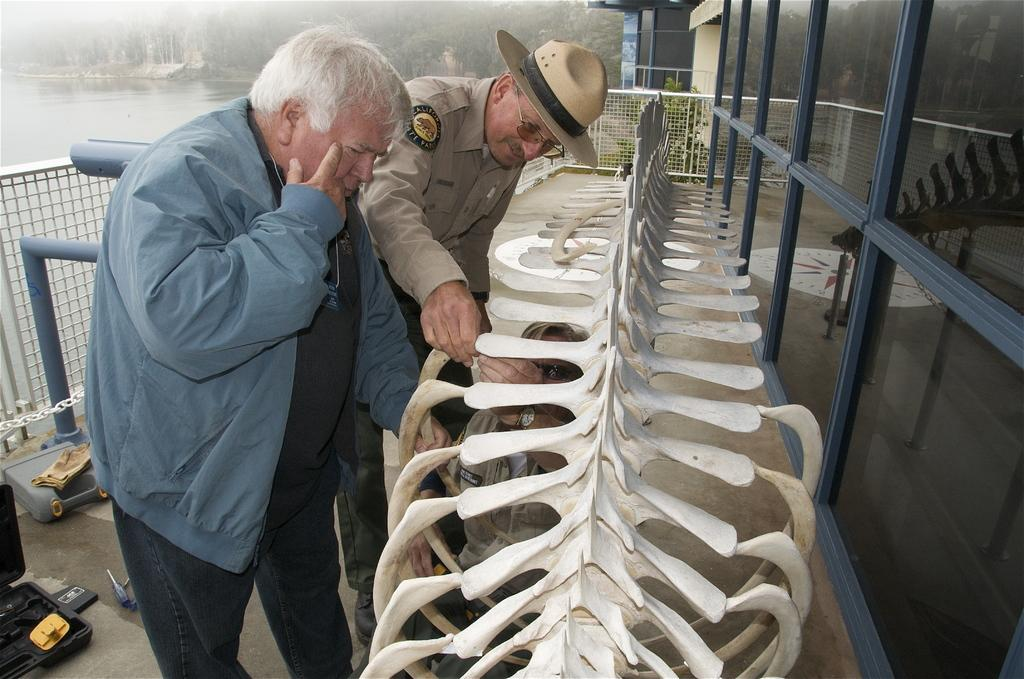How many people are in the foreground of the image? There are three persons in the foreground of the image. What are the persons near in the image? The persons are near a skeleton of an animal. What can be seen in the background of the image? In the background of the image, there are poles, fencing, water, trees, and a glass wall. What type of joke is being told by the skeleton in the image? There is no indication in the image that a joke is being told, nor is there any evidence of a skeleton speaking. 